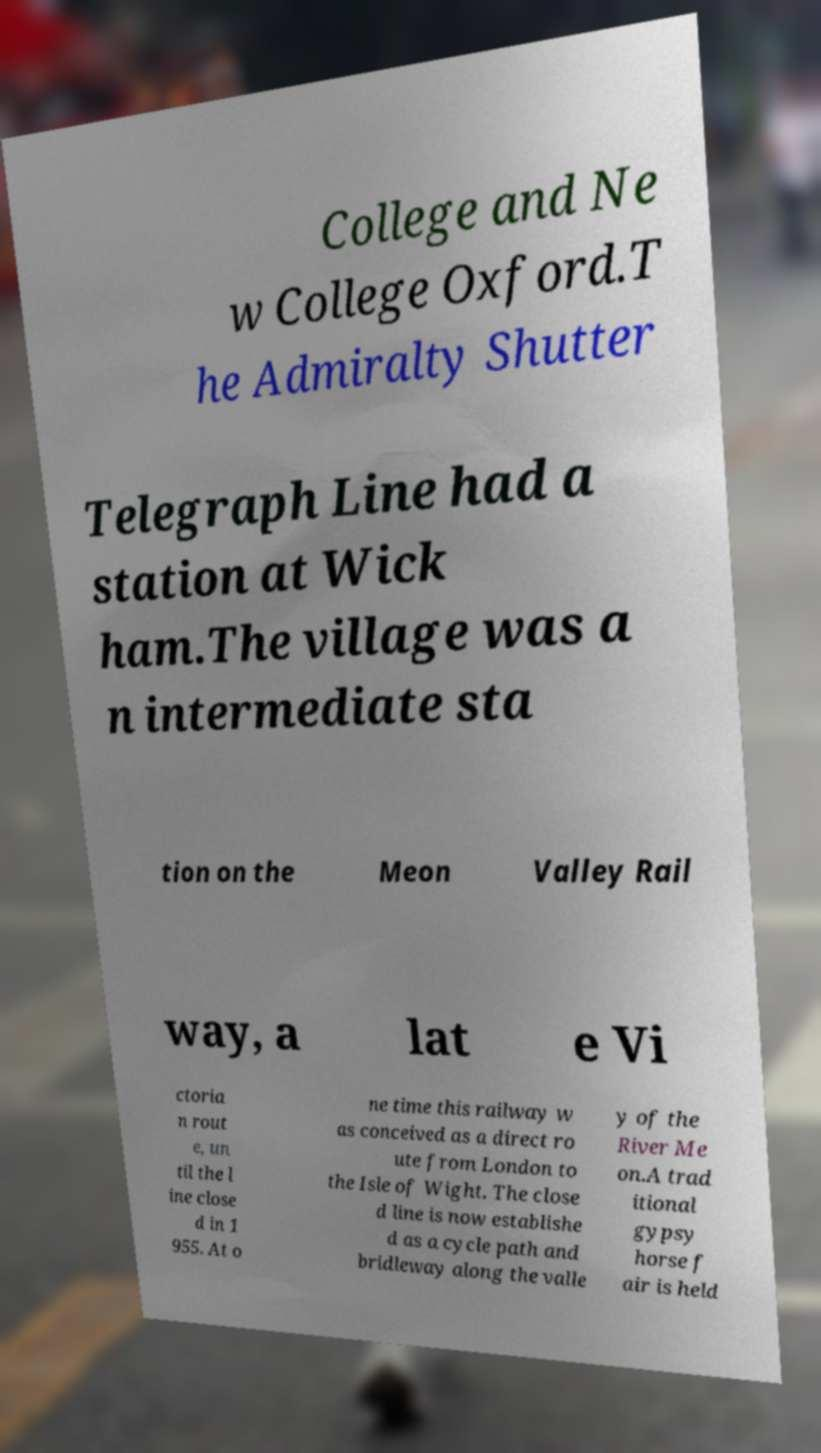I need the written content from this picture converted into text. Can you do that? College and Ne w College Oxford.T he Admiralty Shutter Telegraph Line had a station at Wick ham.The village was a n intermediate sta tion on the Meon Valley Rail way, a lat e Vi ctoria n rout e, un til the l ine close d in 1 955. At o ne time this railway w as conceived as a direct ro ute from London to the Isle of Wight. The close d line is now establishe d as a cycle path and bridleway along the valle y of the River Me on.A trad itional gypsy horse f air is held 